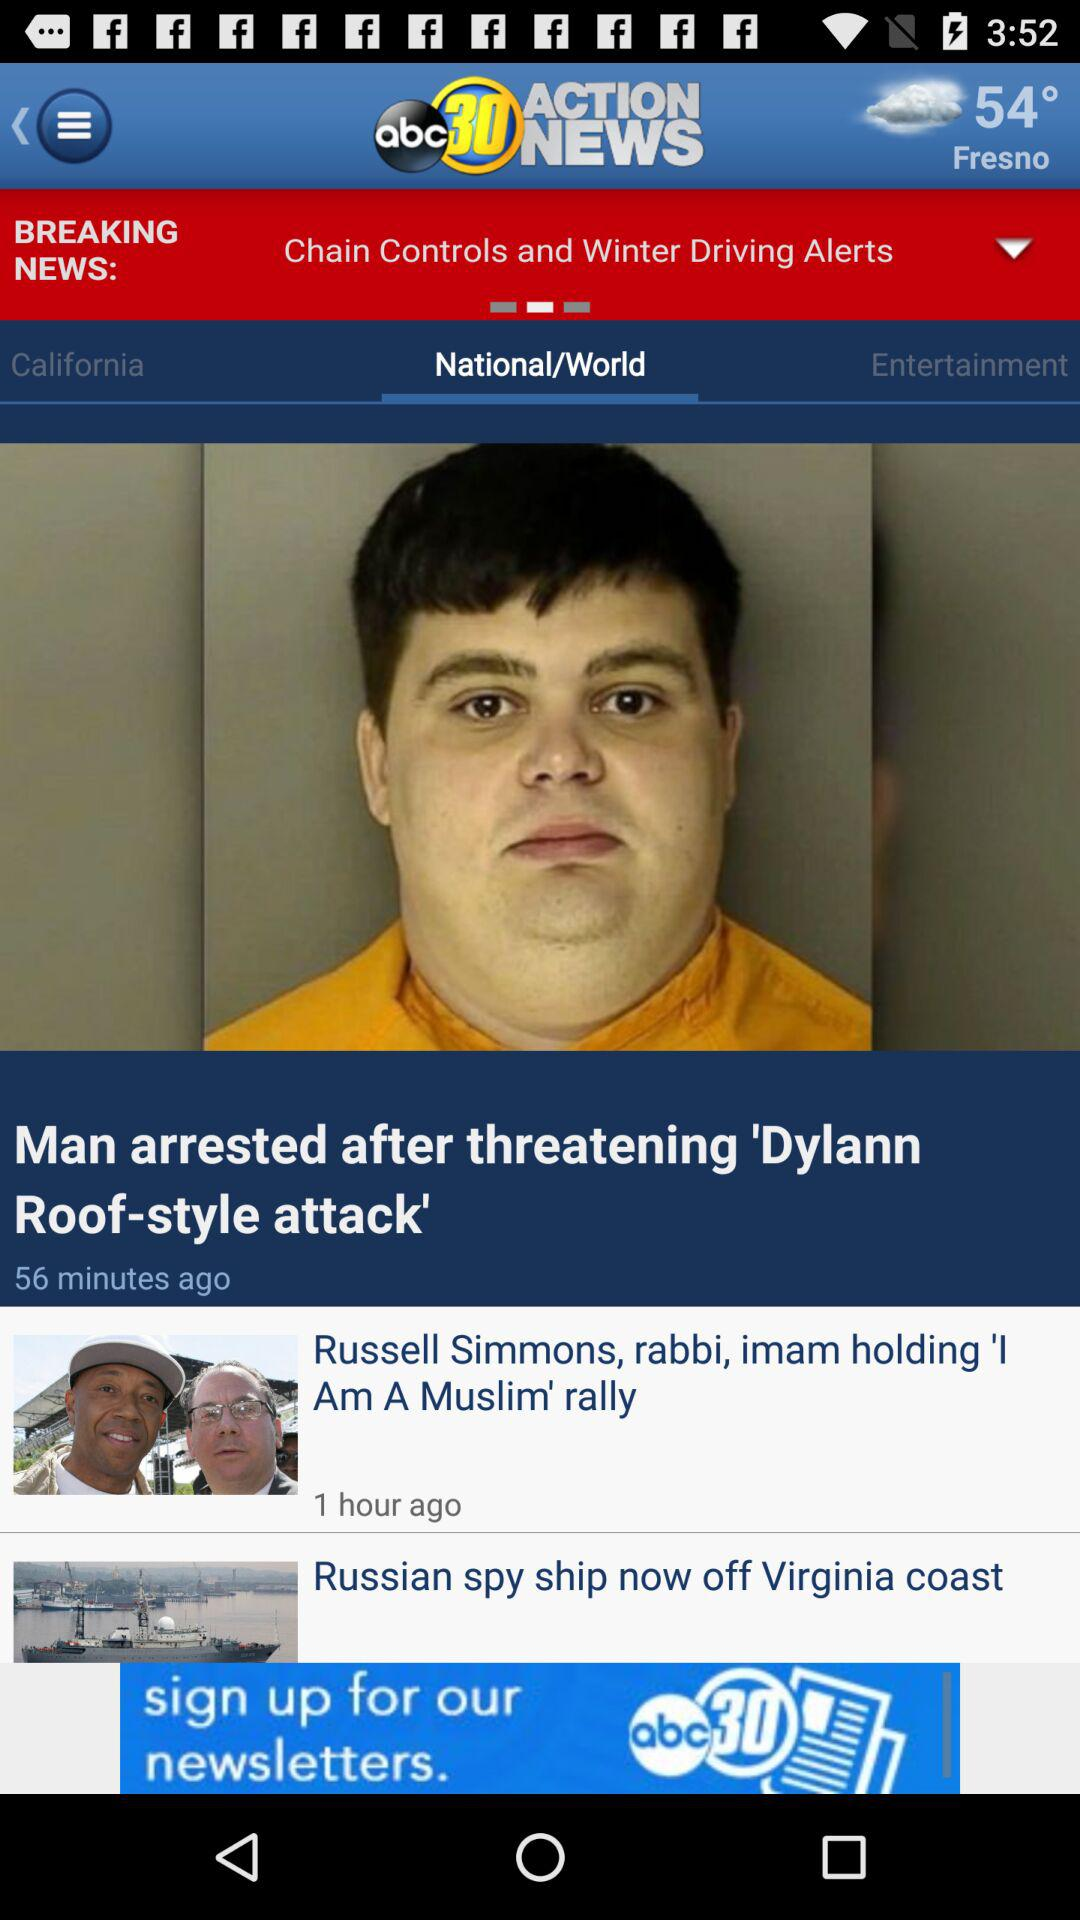What is the application name? The application name is "abc30 ACTION NEWS". 